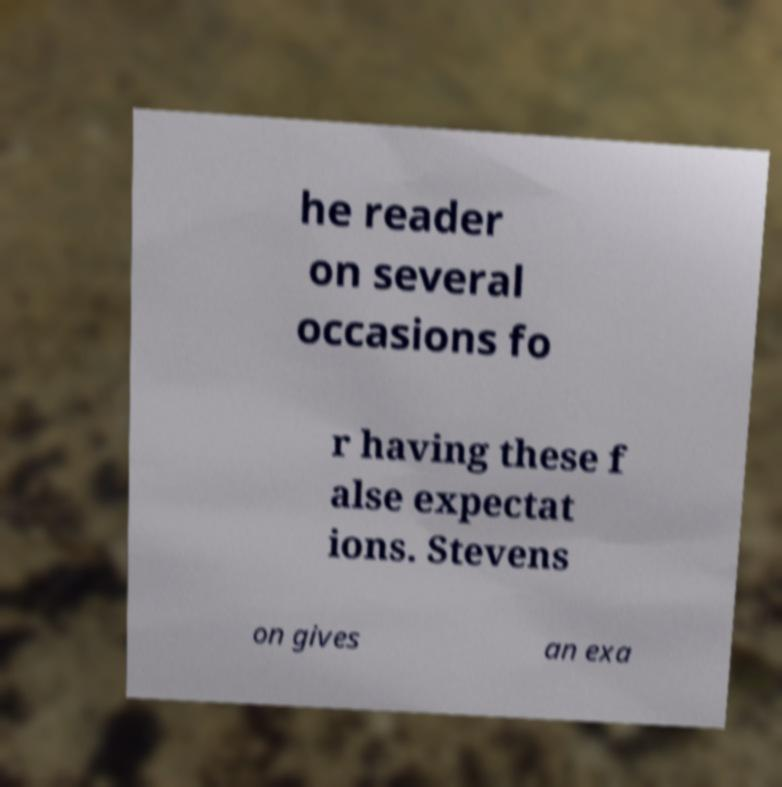What messages or text are displayed in this image? I need them in a readable, typed format. he reader on several occasions fo r having these f alse expectat ions. Stevens on gives an exa 